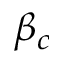<formula> <loc_0><loc_0><loc_500><loc_500>\beta _ { c }</formula> 